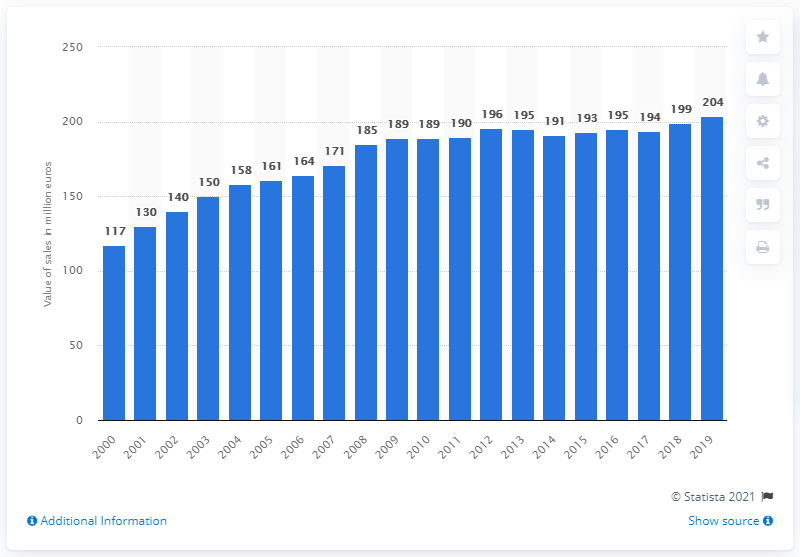List a handful of essential elements in this visual. In 2019, the value of pharmaceutical sales in Luxembourg was 204 million euros. 